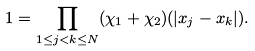<formula> <loc_0><loc_0><loc_500><loc_500>1 = \prod _ { 1 \leq j < k \leq N } ( \chi _ { 1 } + \chi _ { 2 } ) ( | x _ { j } - x _ { k } | ) .</formula> 